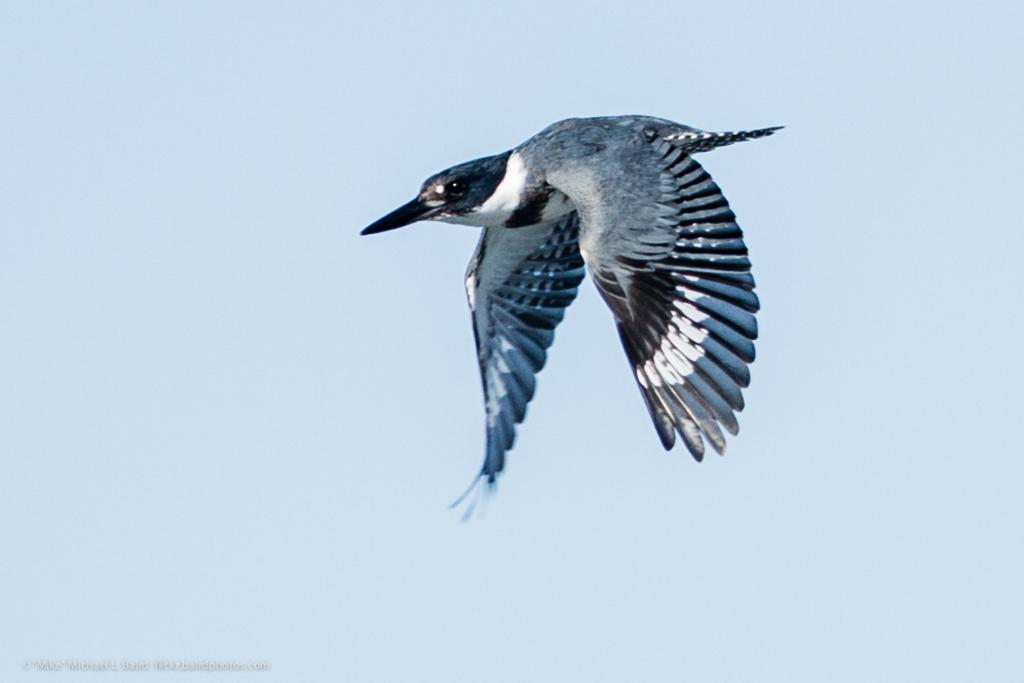What is the main subject of the picture? The main subject of the picture is a bird flying. What can be seen in the background of the picture? The sky is visible in the picture. Is there any text present in the image? Yes, there is text at the bottom left corner of the picture. Where is the stove located in the picture? There is no stove present in the picture; it features a bird flying in the sky. What type of place is depicted in the image? The image does not depict a specific place; it shows a bird flying in the sky against a background of the sky. 